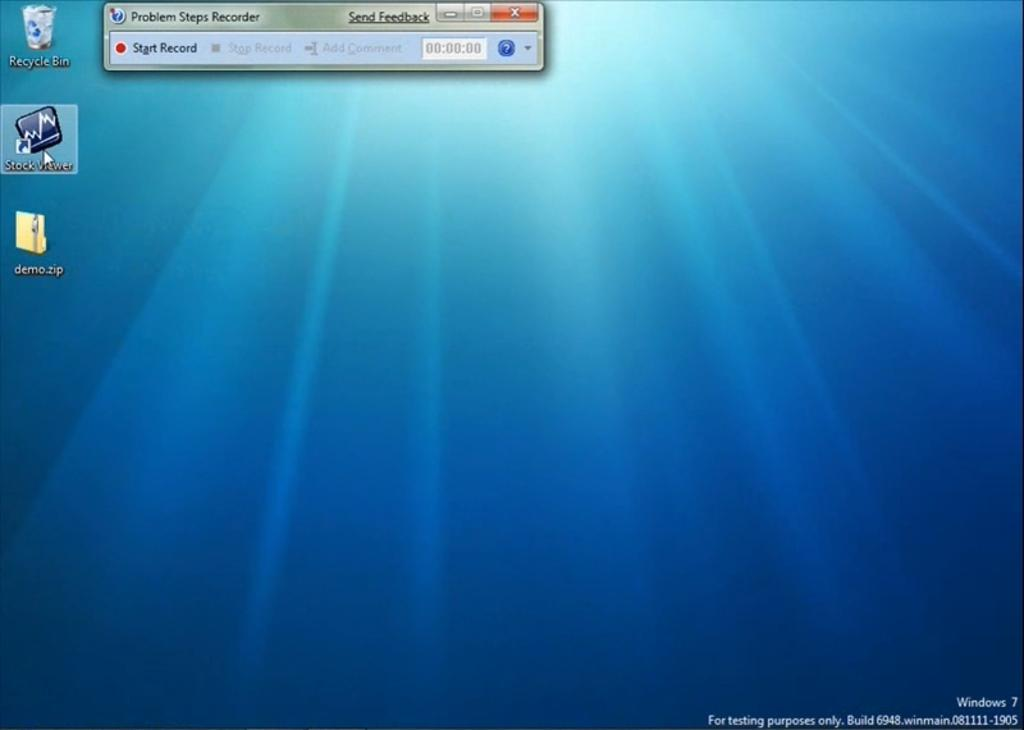<image>
Describe the image concisely. A windows 7 home screen running Problem Steps Recorder. 